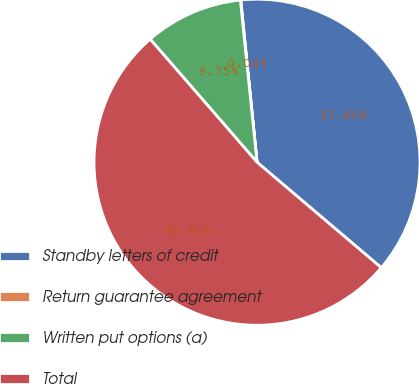Convert chart. <chart><loc_0><loc_0><loc_500><loc_500><pie_chart><fcel>Standby letters of credit<fcel>Return guarantee agreement<fcel>Written put options (a)<fcel>Total<nl><fcel>37.8%<fcel>0.04%<fcel>9.75%<fcel>52.42%<nl></chart> 